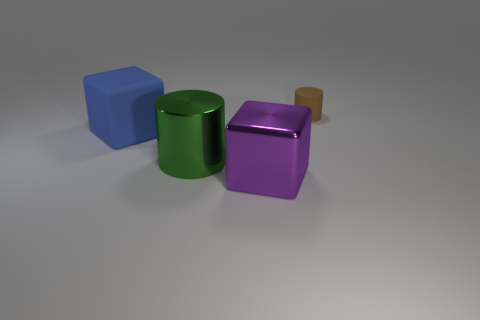Add 1 green shiny things. How many objects exist? 5 Subtract all blue cylinders. How many purple blocks are left? 1 Subtract all big gray metallic things. Subtract all small objects. How many objects are left? 3 Add 4 rubber cylinders. How many rubber cylinders are left? 5 Add 4 blue matte things. How many blue matte things exist? 5 Subtract 0 yellow spheres. How many objects are left? 4 Subtract all green cylinders. Subtract all green spheres. How many cylinders are left? 1 